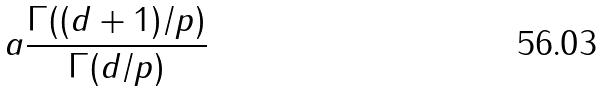Convert formula to latex. <formula><loc_0><loc_0><loc_500><loc_500>a \frac { \Gamma ( ( d + 1 ) / p ) } { \Gamma ( d / p ) }</formula> 